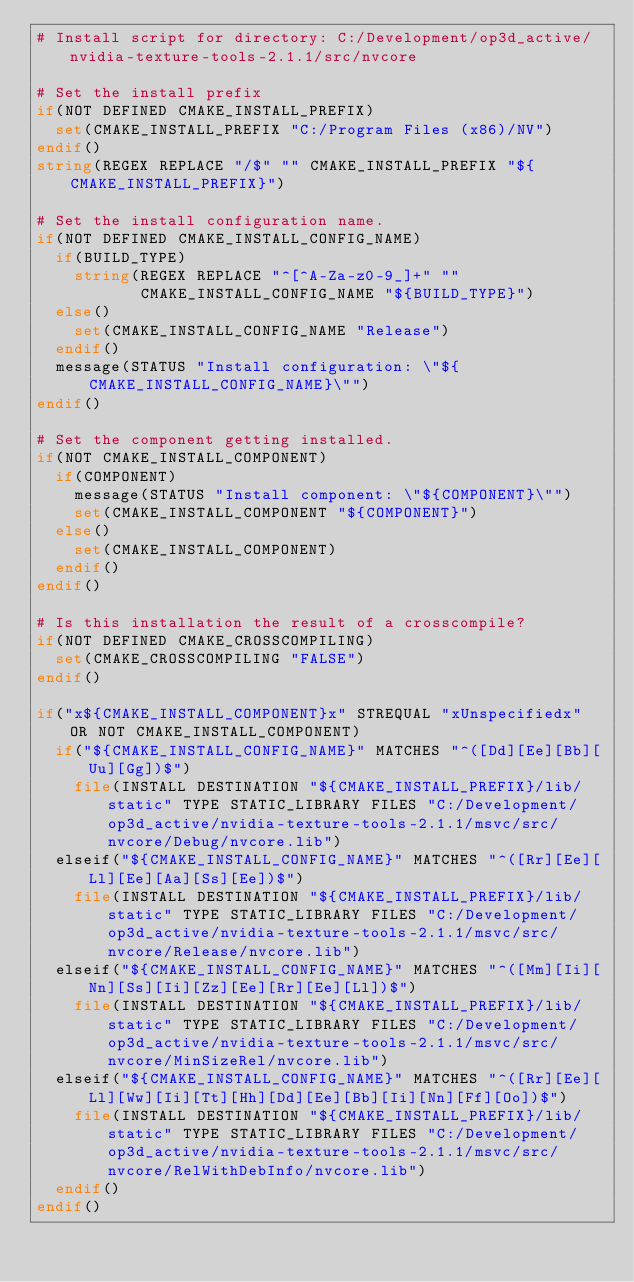<code> <loc_0><loc_0><loc_500><loc_500><_CMake_># Install script for directory: C:/Development/op3d_active/nvidia-texture-tools-2.1.1/src/nvcore

# Set the install prefix
if(NOT DEFINED CMAKE_INSTALL_PREFIX)
  set(CMAKE_INSTALL_PREFIX "C:/Program Files (x86)/NV")
endif()
string(REGEX REPLACE "/$" "" CMAKE_INSTALL_PREFIX "${CMAKE_INSTALL_PREFIX}")

# Set the install configuration name.
if(NOT DEFINED CMAKE_INSTALL_CONFIG_NAME)
  if(BUILD_TYPE)
    string(REGEX REPLACE "^[^A-Za-z0-9_]+" ""
           CMAKE_INSTALL_CONFIG_NAME "${BUILD_TYPE}")
  else()
    set(CMAKE_INSTALL_CONFIG_NAME "Release")
  endif()
  message(STATUS "Install configuration: \"${CMAKE_INSTALL_CONFIG_NAME}\"")
endif()

# Set the component getting installed.
if(NOT CMAKE_INSTALL_COMPONENT)
  if(COMPONENT)
    message(STATUS "Install component: \"${COMPONENT}\"")
    set(CMAKE_INSTALL_COMPONENT "${COMPONENT}")
  else()
    set(CMAKE_INSTALL_COMPONENT)
  endif()
endif()

# Is this installation the result of a crosscompile?
if(NOT DEFINED CMAKE_CROSSCOMPILING)
  set(CMAKE_CROSSCOMPILING "FALSE")
endif()

if("x${CMAKE_INSTALL_COMPONENT}x" STREQUAL "xUnspecifiedx" OR NOT CMAKE_INSTALL_COMPONENT)
  if("${CMAKE_INSTALL_CONFIG_NAME}" MATCHES "^([Dd][Ee][Bb][Uu][Gg])$")
    file(INSTALL DESTINATION "${CMAKE_INSTALL_PREFIX}/lib/static" TYPE STATIC_LIBRARY FILES "C:/Development/op3d_active/nvidia-texture-tools-2.1.1/msvc/src/nvcore/Debug/nvcore.lib")
  elseif("${CMAKE_INSTALL_CONFIG_NAME}" MATCHES "^([Rr][Ee][Ll][Ee][Aa][Ss][Ee])$")
    file(INSTALL DESTINATION "${CMAKE_INSTALL_PREFIX}/lib/static" TYPE STATIC_LIBRARY FILES "C:/Development/op3d_active/nvidia-texture-tools-2.1.1/msvc/src/nvcore/Release/nvcore.lib")
  elseif("${CMAKE_INSTALL_CONFIG_NAME}" MATCHES "^([Mm][Ii][Nn][Ss][Ii][Zz][Ee][Rr][Ee][Ll])$")
    file(INSTALL DESTINATION "${CMAKE_INSTALL_PREFIX}/lib/static" TYPE STATIC_LIBRARY FILES "C:/Development/op3d_active/nvidia-texture-tools-2.1.1/msvc/src/nvcore/MinSizeRel/nvcore.lib")
  elseif("${CMAKE_INSTALL_CONFIG_NAME}" MATCHES "^([Rr][Ee][Ll][Ww][Ii][Tt][Hh][Dd][Ee][Bb][Ii][Nn][Ff][Oo])$")
    file(INSTALL DESTINATION "${CMAKE_INSTALL_PREFIX}/lib/static" TYPE STATIC_LIBRARY FILES "C:/Development/op3d_active/nvidia-texture-tools-2.1.1/msvc/src/nvcore/RelWithDebInfo/nvcore.lib")
  endif()
endif()

</code> 